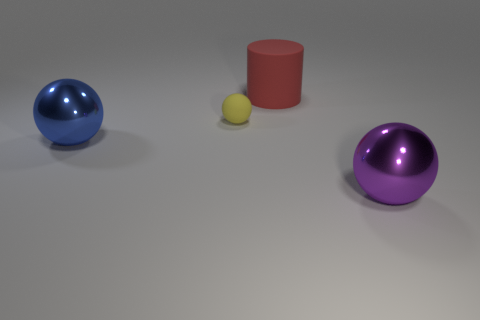How many other cylinders are the same color as the rubber cylinder?
Give a very brief answer. 0. The big object that is both in front of the big matte cylinder and on the right side of the tiny thing has what shape?
Keep it short and to the point. Sphere. What is the color of the sphere that is in front of the tiny yellow thing and to the right of the big blue ball?
Your response must be concise. Purple. Are there more big rubber things that are in front of the big purple thing than big matte cylinders that are left of the tiny object?
Give a very brief answer. No. There is a metallic object left of the small rubber thing; what is its color?
Provide a succinct answer. Blue. Do the big matte object to the right of the big blue metallic sphere and the thing left of the tiny yellow rubber thing have the same shape?
Make the answer very short. No. Are there any purple objects of the same size as the yellow matte object?
Keep it short and to the point. No. What is the material of the big sphere that is on the right side of the blue object?
Make the answer very short. Metal. Is the material of the thing that is in front of the blue object the same as the red cylinder?
Provide a succinct answer. No. Are any tiny cyan things visible?
Make the answer very short. No. 